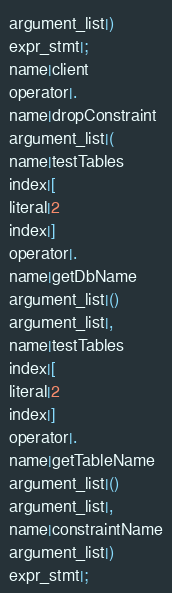<code> <loc_0><loc_0><loc_500><loc_500><_Java_>argument_list|)
expr_stmt|;
name|client
operator|.
name|dropConstraint
argument_list|(
name|testTables
index|[
literal|2
index|]
operator|.
name|getDbName
argument_list|()
argument_list|,
name|testTables
index|[
literal|2
index|]
operator|.
name|getTableName
argument_list|()
argument_list|,
name|constraintName
argument_list|)
expr_stmt|;</code> 